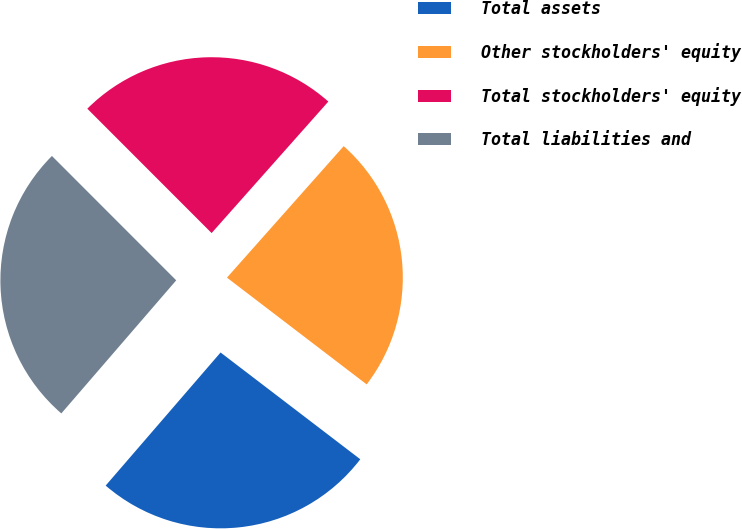Convert chart to OTSL. <chart><loc_0><loc_0><loc_500><loc_500><pie_chart><fcel>Total assets<fcel>Other stockholders' equity<fcel>Total stockholders' equity<fcel>Total liabilities and<nl><fcel>25.95%<fcel>23.83%<fcel>24.05%<fcel>26.17%<nl></chart> 